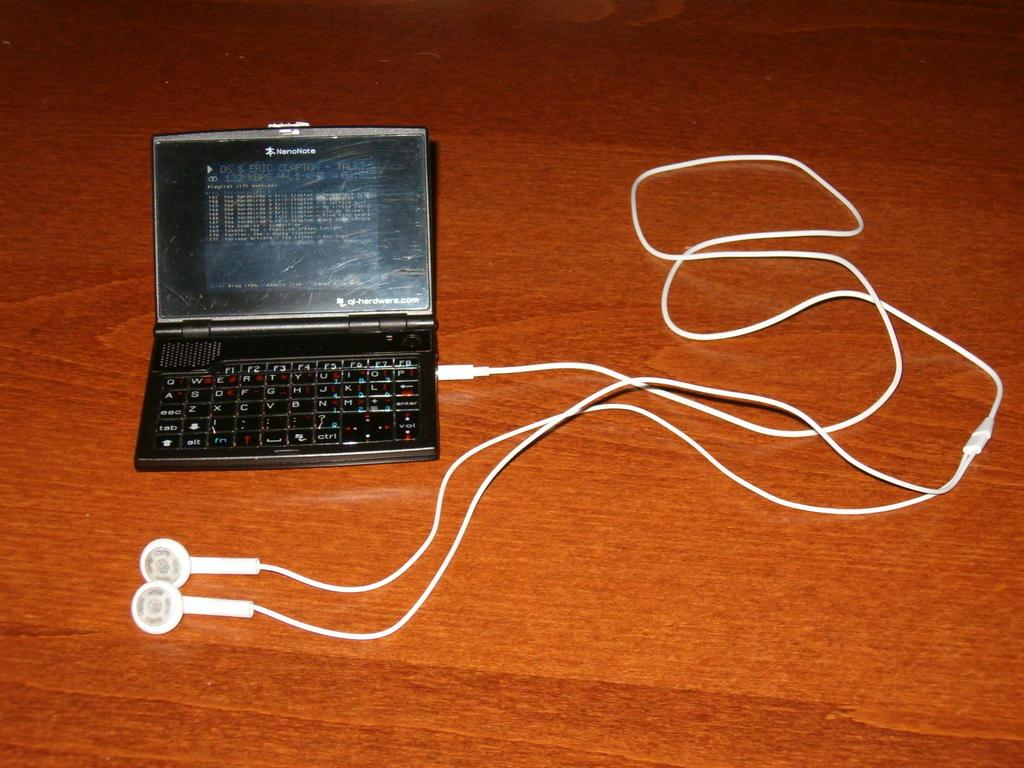<image>
Share a concise interpretation of the image provided. A black device says Nanonote and has ear bug plugged into it. 